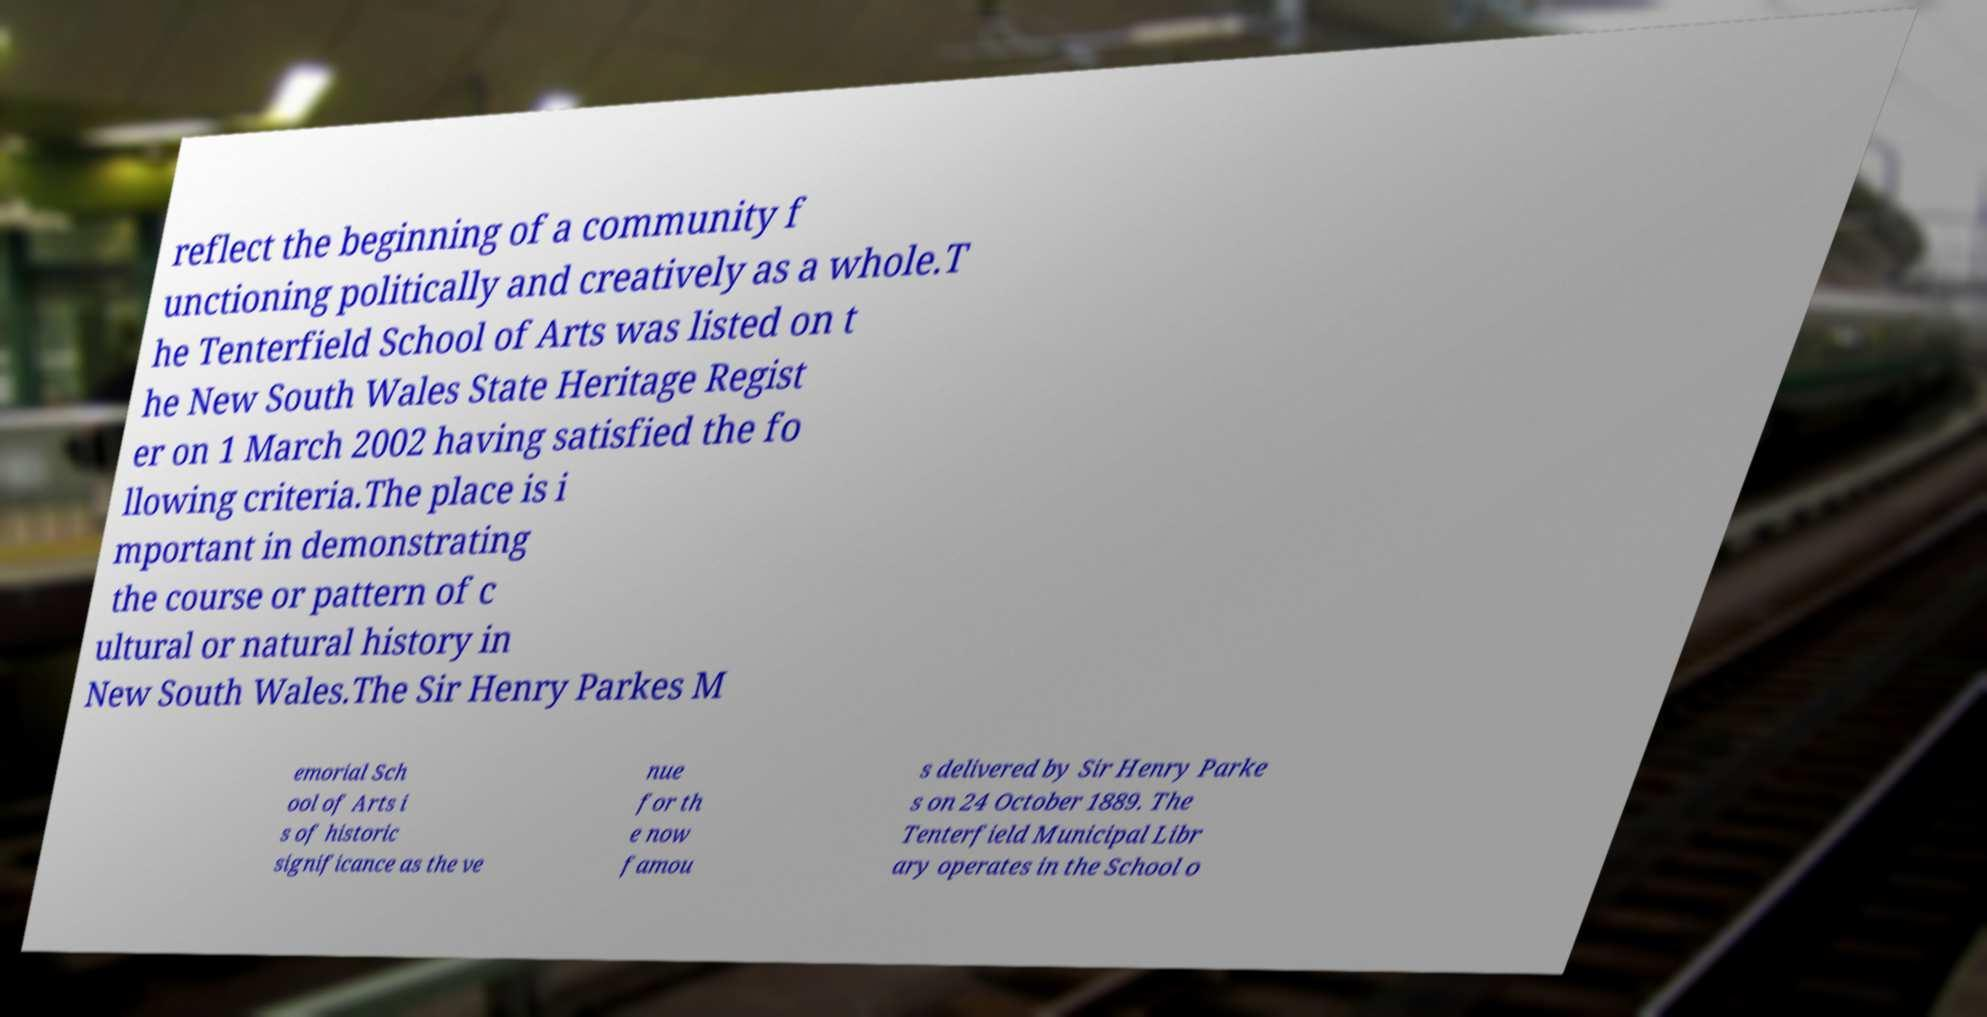There's text embedded in this image that I need extracted. Can you transcribe it verbatim? reflect the beginning of a community f unctioning politically and creatively as a whole.T he Tenterfield School of Arts was listed on t he New South Wales State Heritage Regist er on 1 March 2002 having satisfied the fo llowing criteria.The place is i mportant in demonstrating the course or pattern of c ultural or natural history in New South Wales.The Sir Henry Parkes M emorial Sch ool of Arts i s of historic significance as the ve nue for th e now famou s delivered by Sir Henry Parke s on 24 October 1889. The Tenterfield Municipal Libr ary operates in the School o 